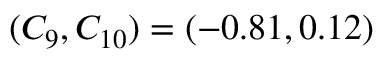Convert formula to latex. <formula><loc_0><loc_0><loc_500><loc_500>( C _ { 9 } , C _ { 1 0 } ) = ( - 0 . 8 1 , 0 . 1 2 )</formula> 